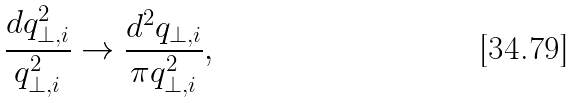<formula> <loc_0><loc_0><loc_500><loc_500>\frac { d q _ { \perp , i } ^ { 2 } } { q _ { \perp , i } ^ { 2 } } \rightarrow \frac { d ^ { 2 } q _ { \perp , i } } { \pi q _ { \perp , i } ^ { 2 } } ,</formula> 